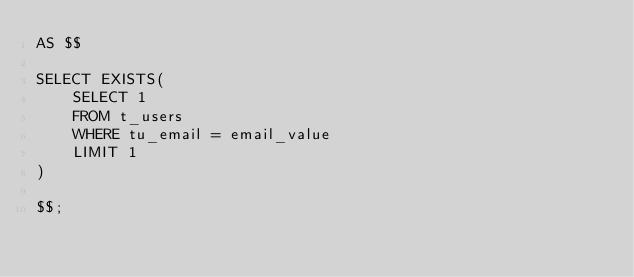Convert code to text. <code><loc_0><loc_0><loc_500><loc_500><_SQL_>AS $$

SELECT EXISTS(
    SELECT 1
    FROM t_users
    WHERE tu_email = email_value
    LIMIT 1
)

$$;
</code> 